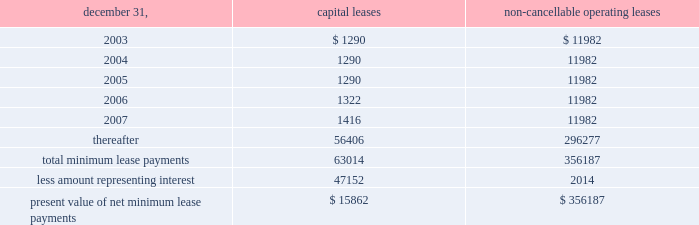N o t e s t o c o n s o l i d a t e d f i n a n c i a l s t a t e m e n t s ( c o n t i n u e d ) the realization of this investment gain ( $ 5624 net of the award ) .
This award , which will be paid out over a three-year period , is presented as deferred compensation award on the balance sheet .
As of december 31 , 2002 , $ 1504 had been paid against this compensation award .
401 ( k ) plan during august 1997 , the company implemented a 401 ( k ) savings/retirement plan ( the 201c401 ( k ) plan 201d ) to cover eligible employees of the company and any designated affiliate .
The 401 ( k ) plan permits eligible employees of the company to defer up to 15% ( 15 % ) of their annual compensation , subject to cer- tain limitations imposed by the code .
The employees 2019 elec- tive deferrals are immediately vested and non-forfeitable upon contribution to the 401 ( k ) plan .
During 2000 , the company amended its 401 ( k ) plan to include a matching contribution , subject to erisa limitations , equal to 50% ( 50 % ) of the first 4% ( 4 % ) of annual compensation deferred by an employee .
For the years ended december 31 , 2002 , 2001 and 2000 , the company made matching contributions of $ 140 , $ 116 and $ 54 , respectively .
18 .
Commitments and contingencies the company and the operating partnership are not presently involved in any material litigation nor , to their knowledge , is any material litigation threatened against them or their properties , other than routine litigation arising in the ordinary course of business .
Management believes the costs , if any , incurred by the company and the operating partnership related to this litigation will not materially affect the financial position , operating results or liquidity of the company and the operating partnership .
On october 24 , 2001 , an accident occurred at 215 park avenue south , a property which the company manages , but does not own .
Personal injury claims have been filed against the company and others by 11 persons .
The company believes that there is sufficient insurance coverage to cover the cost of such claims , as well as any other personal injury or property claims which may arise .
The company has entered into employment agreements with certain executives .
Six executives have employment agreements which expire between november 2003 and december 2007 .
The cash based compensation associated with these employment agreements totals approximately $ 2125 for 2003 .
During march 1998 , the company acquired an operating sub-leasehold position at 420 lexington avenue .
The oper- ating sub-leasehold position requires annual ground lease payments totaling $ 6000 and sub-leasehold position pay- ments totaling $ 1100 ( excluding an operating sub-lease position purchased january 1999 ) .
The ground lease and sub-leasehold positions expire 2008 .
The company may extend the positions through 2029 at market rents .
The property located at 1140 avenue of the americas operates under a net ground lease ( $ 348 annually ) with a term expiration date of 2016 and with an option to renew for an additional 50 years .
The property located at 711 third avenue operates under an operating sub-lease which expires in 2083 .
Under the sub- lease , the company is responsible for ground rent payments of $ 1600 annually which increased to $ 3100 in july 2001 and will continue for the next ten years .
The ground rent is reset after year ten based on the estimated fair market value of the property .
In april 1988 , the sl green predecessor entered into a lease agreement for property at 673 first avenue in new york city , which has been capitalized for financial statement purposes .
Land was estimated to be approximately 70% ( 70 % ) of the fair market value of the property .
The portion of the lease attributed to land is classified as an operating lease and the remainder as a capital lease .
The initial lease term is 49 years with an option for an additional 26 years .
Beginning in lease years 11 and 25 , the lessor is entitled to additional rent as defined by the lease agreement .
The company continues to lease the 673 first avenue prop- erty which has been classified as a capital lease with a cost basis of $ 12208 and cumulative amortization of $ 3579 and $ 3306 at december 31 , 2002 and 2001 , respectively .
The fol- lowing is a schedule of future minimum lease payments under capital leases and noncancellable operating leases with initial terms in excess of one year as of december 31 , 2002 .
Non-cancellable operating december 31 , capital leases leases .
19 .
Financial instruments : derivatives and hedging financial accounting standards board 2019s statement no .
133 , 201caccounting for derivative instruments and hedging activities , 201d ( 201csfas 133 201d ) which became effective january 1 , 2001 requires the company to recognize all derivatives on the balance sheet at fair value .
Derivatives that are not hedges must be adjusted to fair value through income .
If a derivative is a hedge , depending on the nature of the hedge , f i f t y - t w o s l g r e e n r e a l t y c o r p . .
The lessor is entitled to additional rent as defined by the lease agreement for what percentage of the original agreement? 
Computations: (140 / 49)
Answer: 2.85714. 